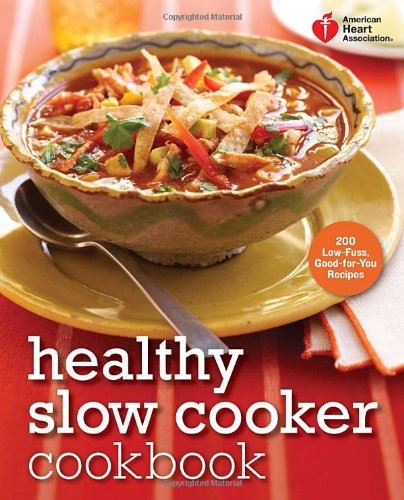What is the title of this book? The title of the book displayed in the image is 'American Heart Association Healthy Slow Cooker Cookbook: 200 Low-Fuss, Good-for-You Recipes (American Heart Association Cookbook)', which suggests a focus on nutritious recipes that are easy to prepare using a slow cooker. 